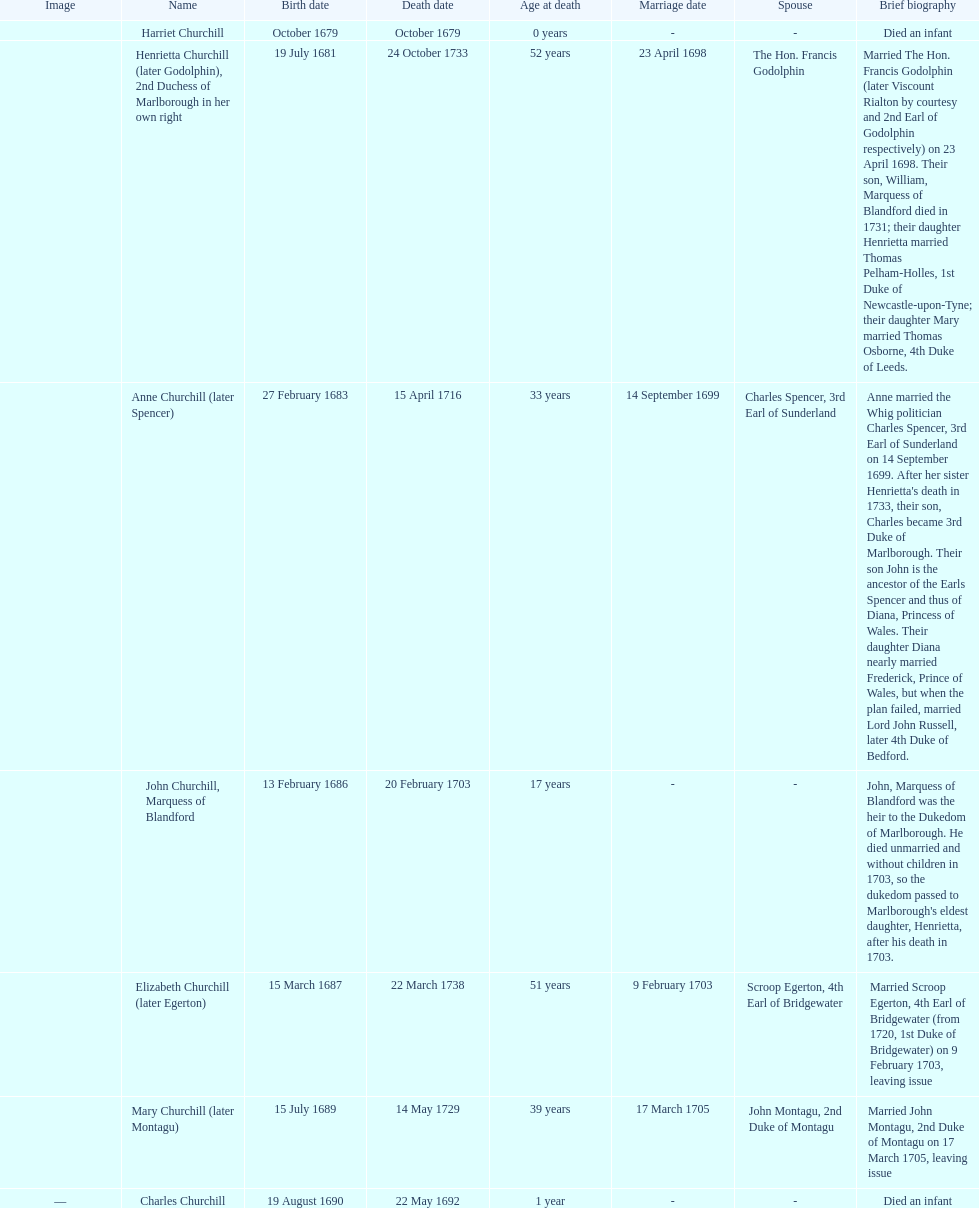How long did anne churchill/spencer live? 33. 